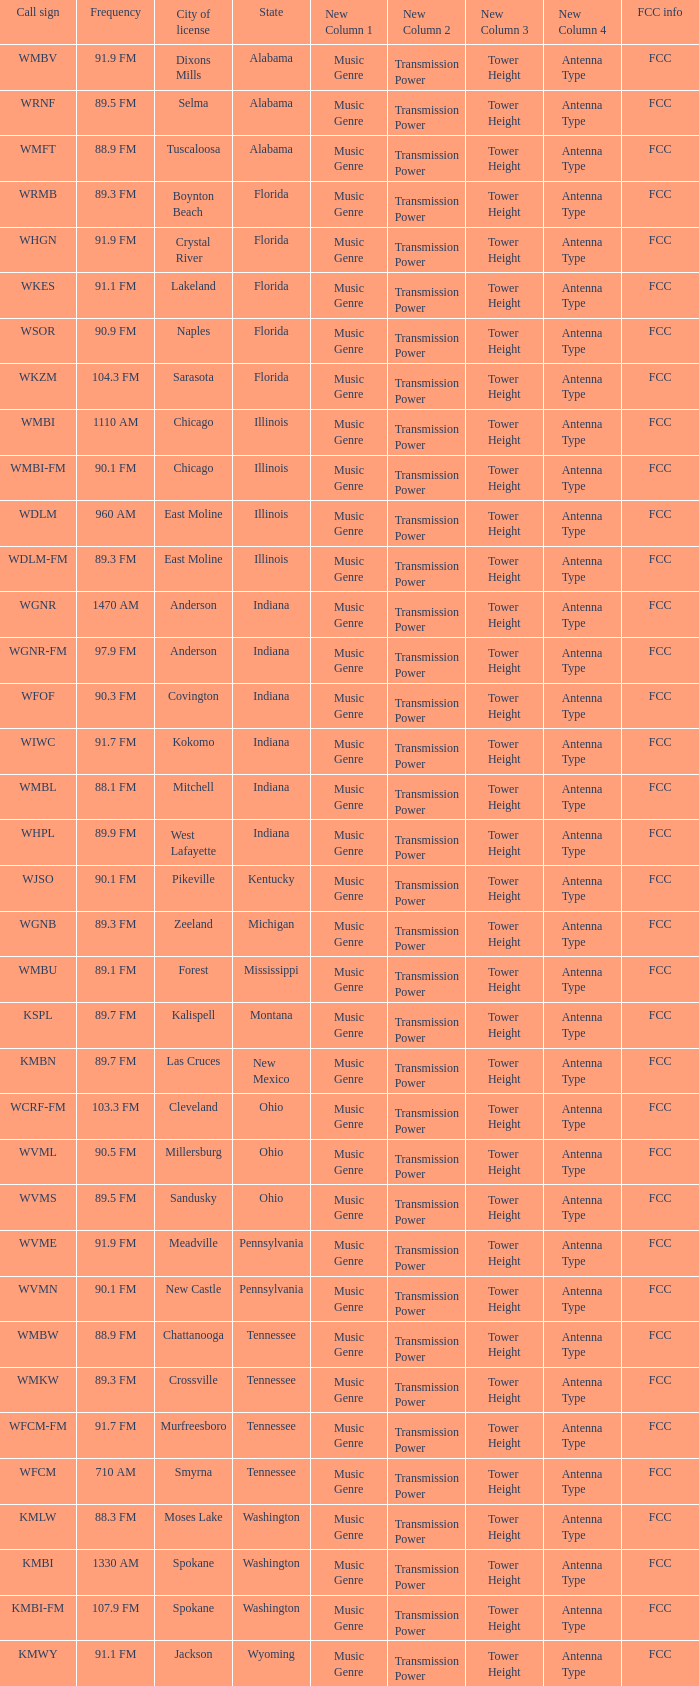What is the call sign for 90.9 FM which is in Florida? WSOR. 